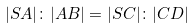Convert formula to latex. <formula><loc_0><loc_0><loc_500><loc_500>| S A | \colon | A B | = | S C | \colon | C D |</formula> 